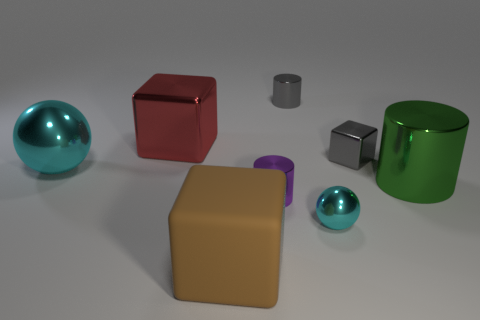Are there any big spheres that have the same color as the small metallic sphere?
Keep it short and to the point. Yes. There is another big thing that is the same shape as the red thing; what is it made of?
Offer a very short reply. Rubber. There is a metal sphere that is on the right side of the small purple object that is in front of the red shiny cube; are there any big brown objects in front of it?
Provide a succinct answer. Yes. There is a big metal thing that is on the left side of the red metallic thing; is it the same shape as the tiny object on the left side of the gray metallic cylinder?
Keep it short and to the point. No. Is the number of tiny metallic things that are behind the small cyan sphere greater than the number of big brown rubber blocks?
Provide a short and direct response. Yes. What number of things are large green cylinders or tiny gray metal cubes?
Offer a terse response. 2. The big cylinder is what color?
Your response must be concise. Green. What number of other things are the same color as the tiny metallic sphere?
Your answer should be compact. 1. Are there any metal cylinders in front of the brown object?
Offer a very short reply. No. There is a ball that is behind the cylinder to the right of the sphere on the right side of the tiny purple cylinder; what is its color?
Ensure brevity in your answer.  Cyan. 